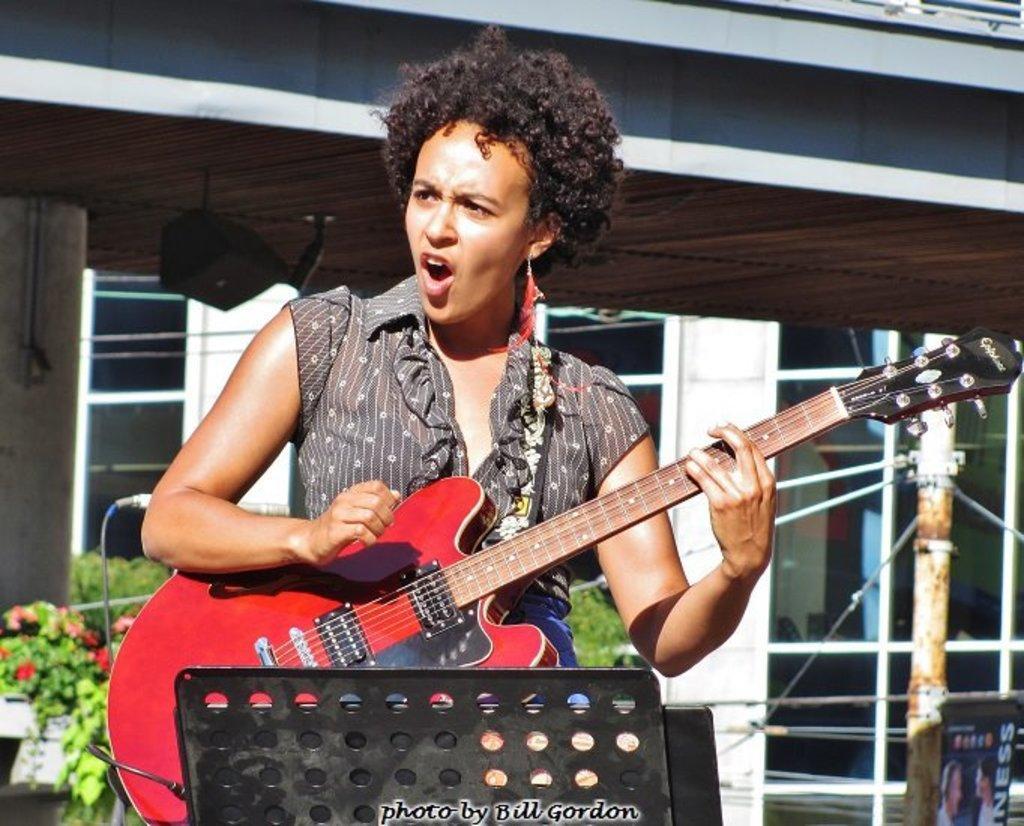Please provide a concise description of this image. In the middle of the image a woman is standing and playing guitar and singing. Behind her there is a building. Bottom left side of the image there are some plants. 